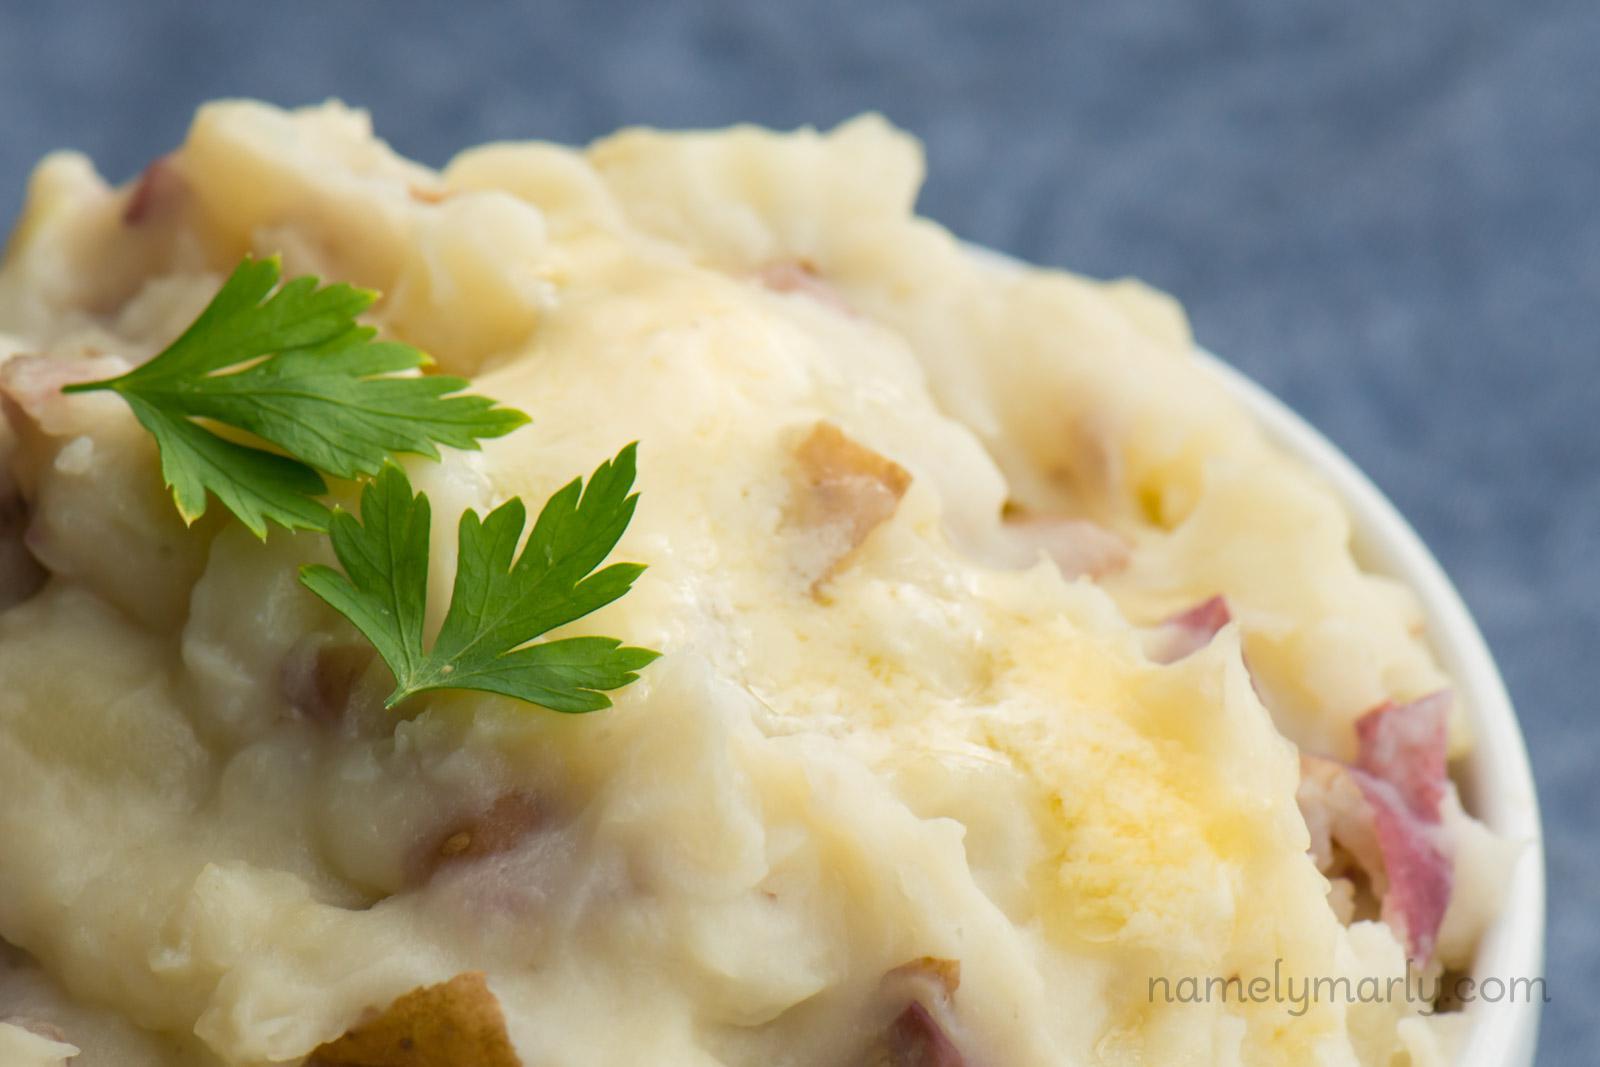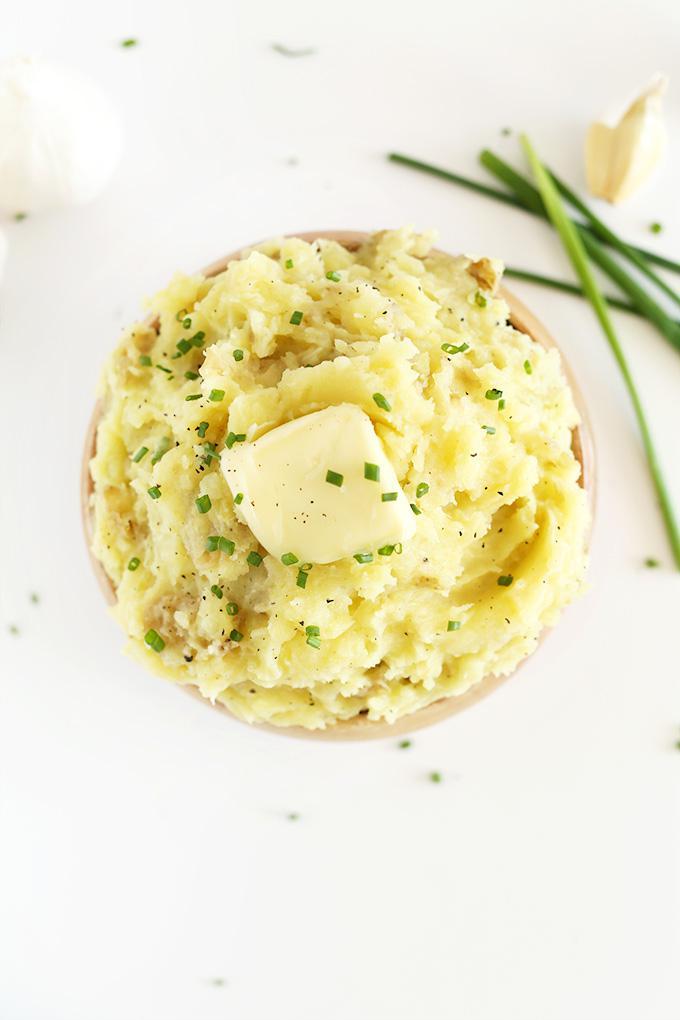The first image is the image on the left, the second image is the image on the right. Analyze the images presented: Is the assertion "One image shows mashed potatoes with chives served in a square white bowl." valid? Answer yes or no. No. 